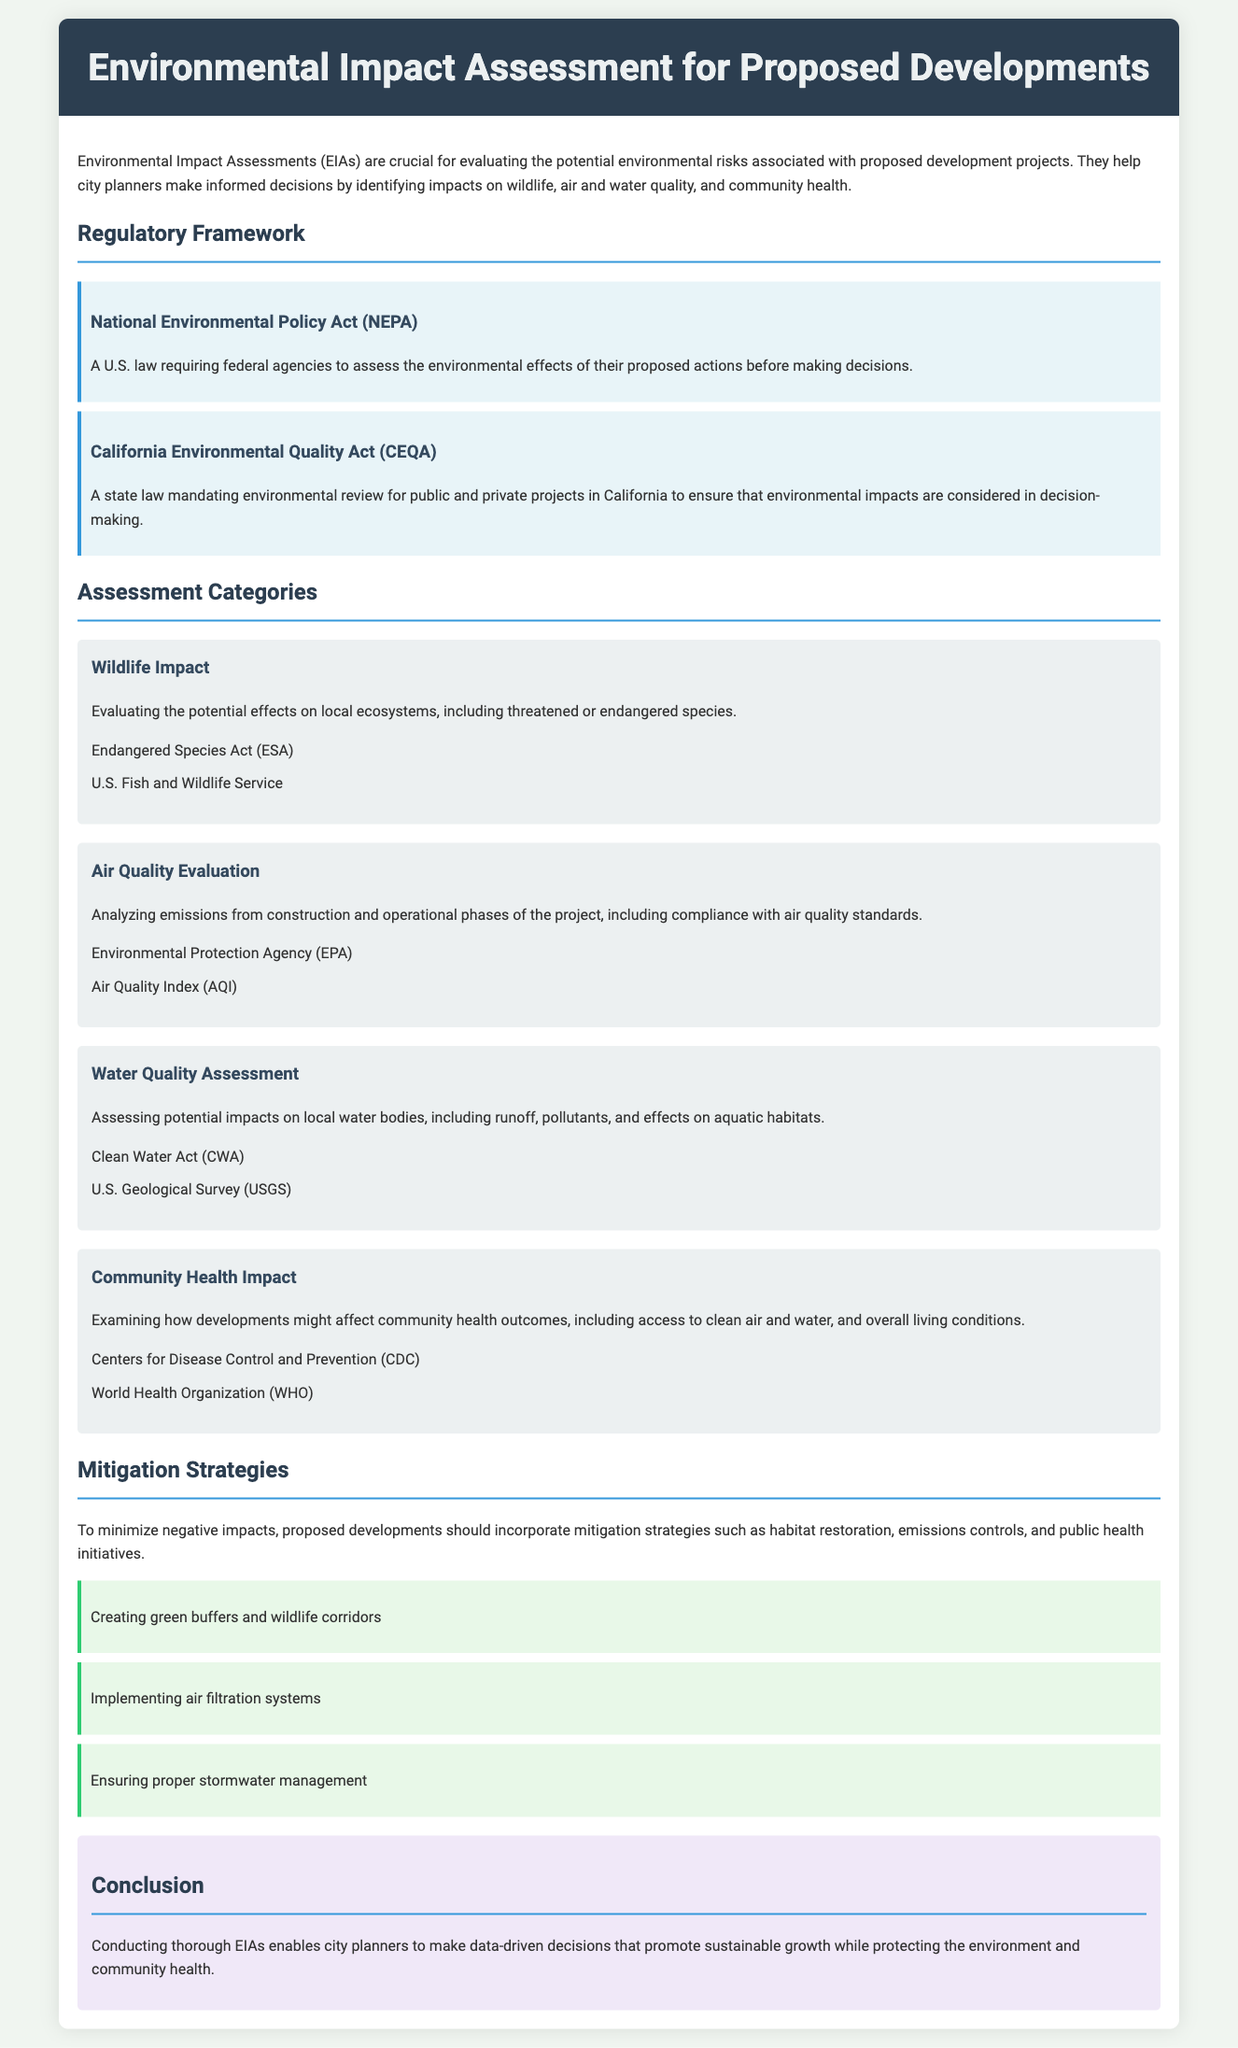What is the title of the document? The title is mentioned in the header section of the document.
Answer: Environmental Impact Assessment for Proposed Developments What does NEPA stand for? NEPA is referred to in the Regulatory Framework section of the document.
Answer: National Environmental Policy Act Which act mandates environmental review for California projects? This information is found under the Regulatory Framework section.
Answer: California Environmental Quality Act What is one of the wildlife impact evaluation aspects? This is mentioned in the Wildlife Impact category of the assessment.
Answer: Threatened or endangered species What agency is associated with air quality evaluation? This is referenced in the Air Quality Evaluation category.
Answer: Environmental Protection Agency What is a proposed mitigation strategy? This information can be found in the Mitigation Strategies section of the document.
Answer: Creating green buffers and wildlife corridors Who are involved in community health assessments? The Community Health Impact category includes specific organizations.
Answer: Centers for Disease Control and Prevention What is the primary goal of conducting thorough EIAs? This is summarized in the conclusion section of the document.
Answer: Promote sustainable growth What is the color of the headers in the document? The color property for headers can be identified in the style section of the HTML code.
Answer: Dark blue 